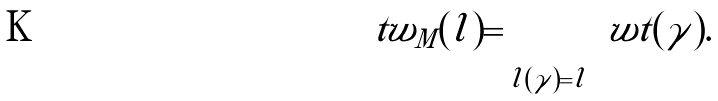Convert formula to latex. <formula><loc_0><loc_0><loc_500><loc_500>\ t w _ { M } ( l ) = \sum _ { l ( \gamma ) = l } \ w t ( \gamma ) .</formula> 